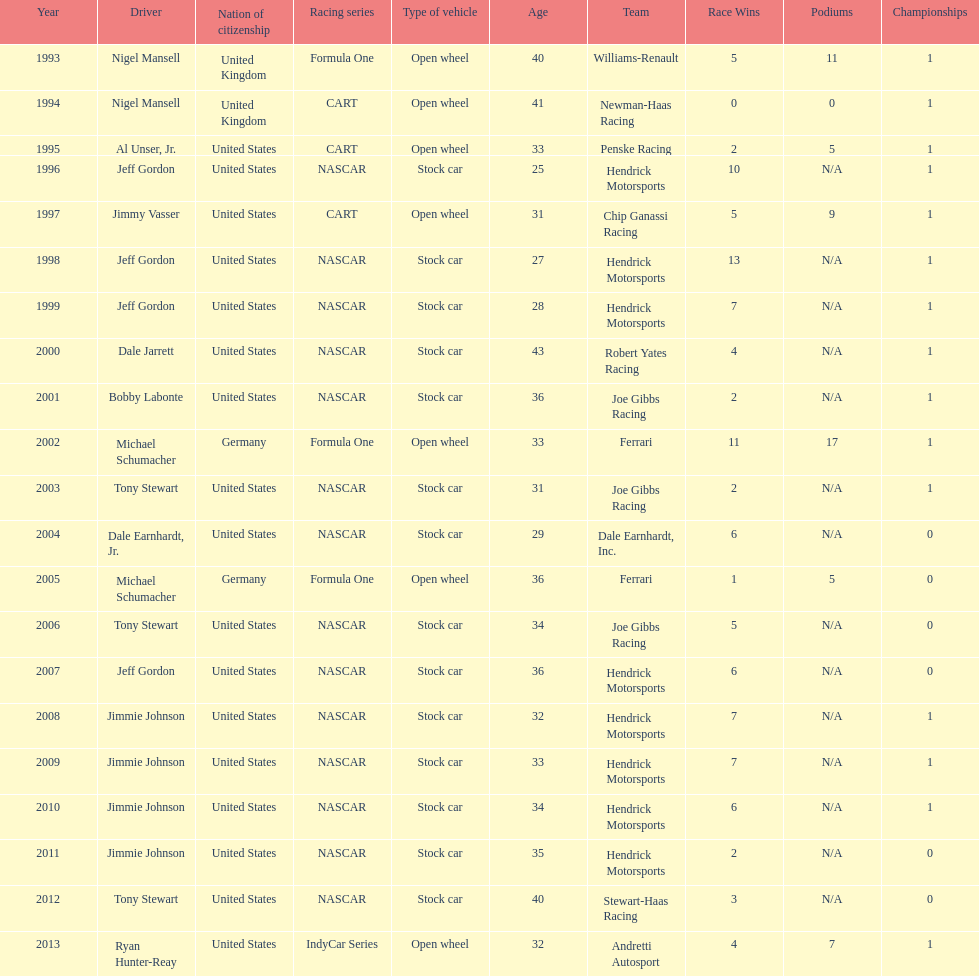Does the united states have more nation of citzenship then united kingdom? Yes. 